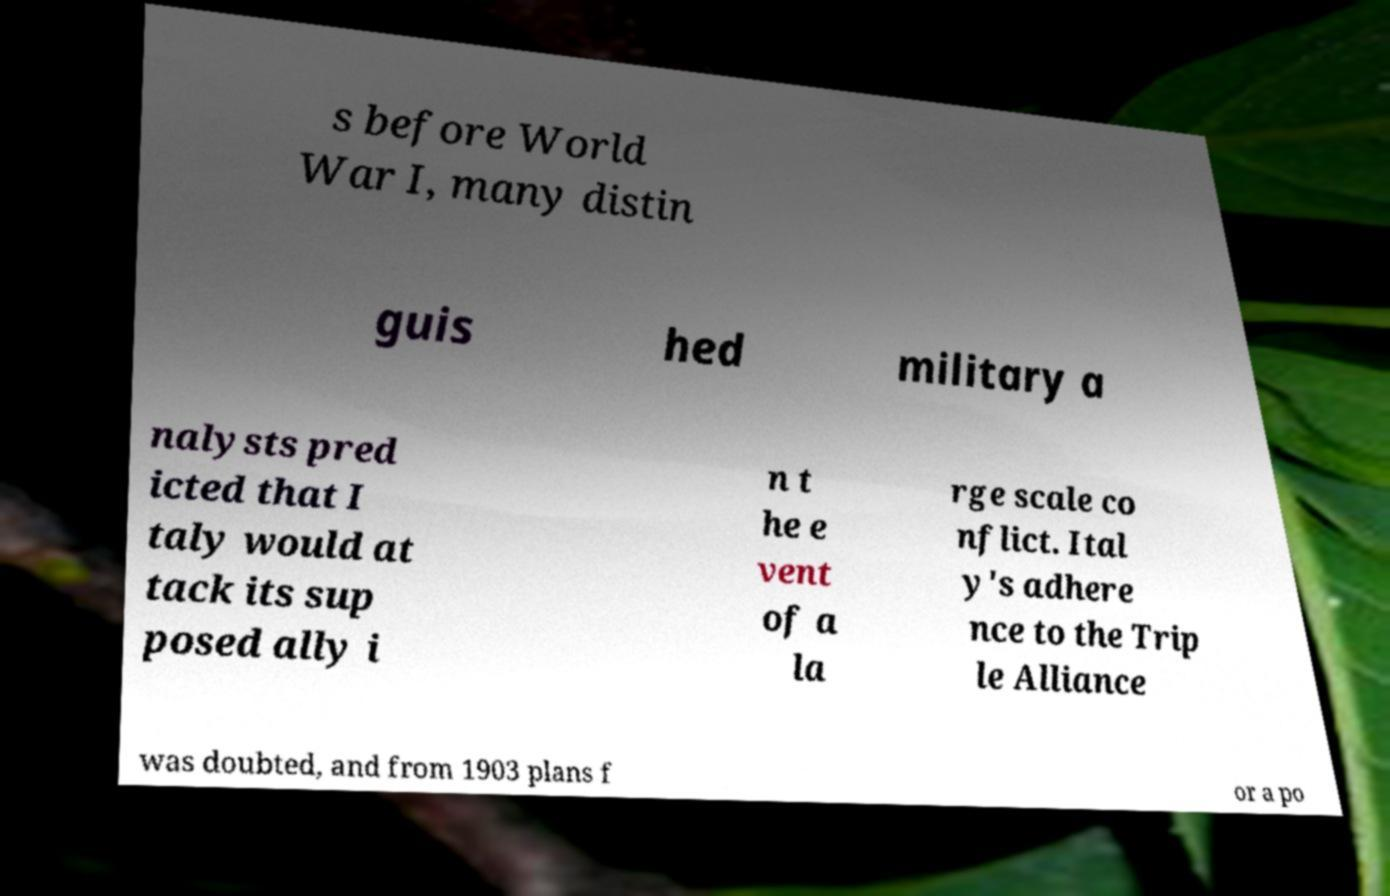Could you assist in decoding the text presented in this image and type it out clearly? s before World War I, many distin guis hed military a nalysts pred icted that I taly would at tack its sup posed ally i n t he e vent of a la rge scale co nflict. Ital y's adhere nce to the Trip le Alliance was doubted, and from 1903 plans f or a po 